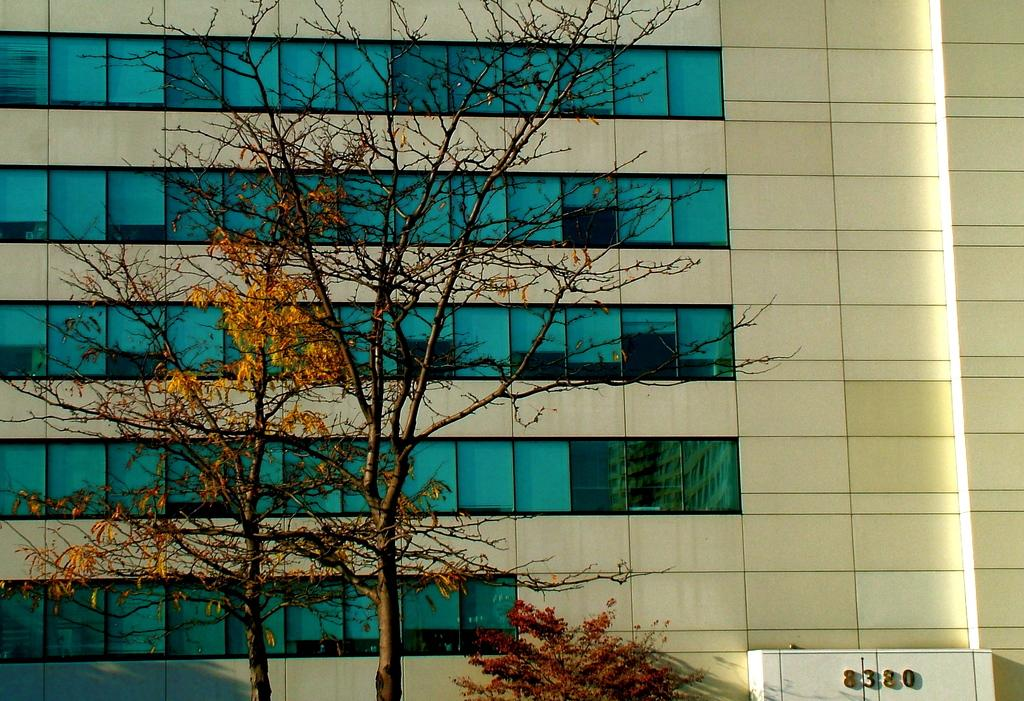What is the main structure in the image? There is a building in the image. What feature can be seen on the building? The building has windows. What type of vegetation is present in the image? There is a tree in front of the building. Can you see the moon behind the building in the image? The moon is not visible in the image; it only shows a building with windows and a tree in front of it. 